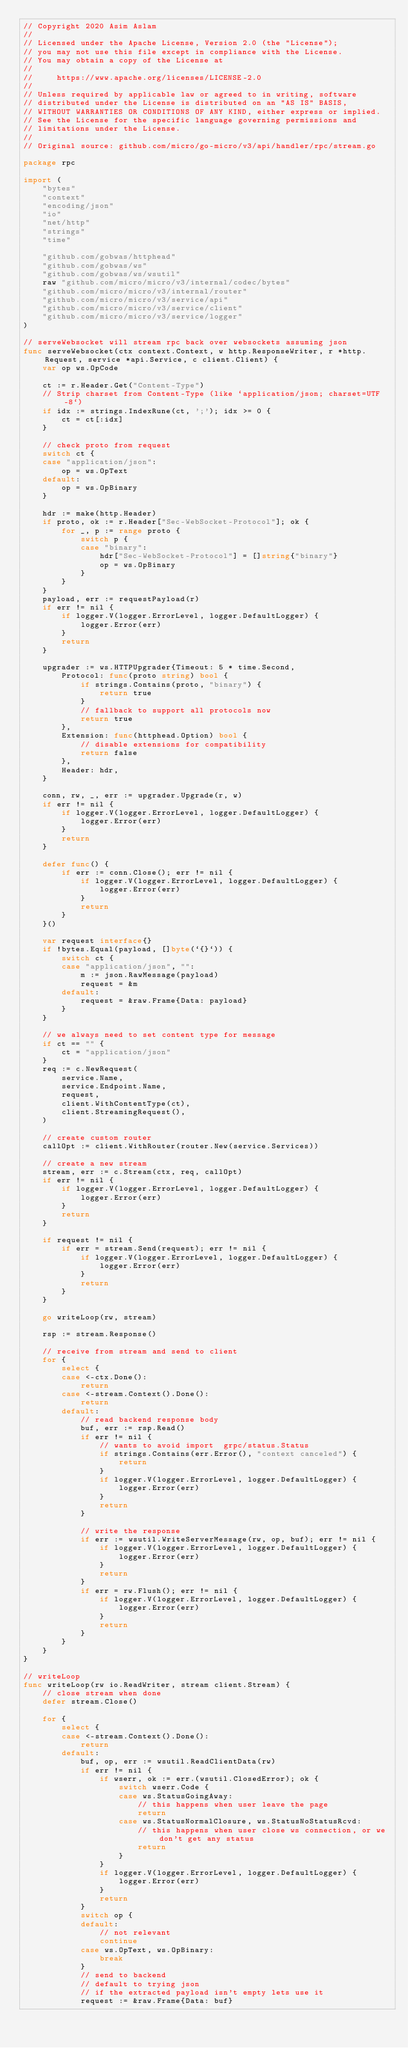<code> <loc_0><loc_0><loc_500><loc_500><_Go_>// Copyright 2020 Asim Aslam
//
// Licensed under the Apache License, Version 2.0 (the "License");
// you may not use this file except in compliance with the License.
// You may obtain a copy of the License at
//
//     https://www.apache.org/licenses/LICENSE-2.0
//
// Unless required by applicable law or agreed to in writing, software
// distributed under the License is distributed on an "AS IS" BASIS,
// WITHOUT WARRANTIES OR CONDITIONS OF ANY KIND, either express or implied.
// See the License for the specific language governing permissions and
// limitations under the License.
//
// Original source: github.com/micro/go-micro/v3/api/handler/rpc/stream.go

package rpc

import (
	"bytes"
	"context"
	"encoding/json"
	"io"
	"net/http"
	"strings"
	"time"

	"github.com/gobwas/httphead"
	"github.com/gobwas/ws"
	"github.com/gobwas/ws/wsutil"
	raw "github.com/micro/micro/v3/internal/codec/bytes"
	"github.com/micro/micro/v3/internal/router"
	"github.com/micro/micro/v3/service/api"
	"github.com/micro/micro/v3/service/client"
	"github.com/micro/micro/v3/service/logger"
)

// serveWebsocket will stream rpc back over websockets assuming json
func serveWebsocket(ctx context.Context, w http.ResponseWriter, r *http.Request, service *api.Service, c client.Client) {
	var op ws.OpCode

	ct := r.Header.Get("Content-Type")
	// Strip charset from Content-Type (like `application/json; charset=UTF-8`)
	if idx := strings.IndexRune(ct, ';'); idx >= 0 {
		ct = ct[:idx]
	}

	// check proto from request
	switch ct {
	case "application/json":
		op = ws.OpText
	default:
		op = ws.OpBinary
	}

	hdr := make(http.Header)
	if proto, ok := r.Header["Sec-WebSocket-Protocol"]; ok {
		for _, p := range proto {
			switch p {
			case "binary":
				hdr["Sec-WebSocket-Protocol"] = []string{"binary"}
				op = ws.OpBinary
			}
		}
	}
	payload, err := requestPayload(r)
	if err != nil {
		if logger.V(logger.ErrorLevel, logger.DefaultLogger) {
			logger.Error(err)
		}
		return
	}

	upgrader := ws.HTTPUpgrader{Timeout: 5 * time.Second,
		Protocol: func(proto string) bool {
			if strings.Contains(proto, "binary") {
				return true
			}
			// fallback to support all protocols now
			return true
		},
		Extension: func(httphead.Option) bool {
			// disable extensions for compatibility
			return false
		},
		Header: hdr,
	}

	conn, rw, _, err := upgrader.Upgrade(r, w)
	if err != nil {
		if logger.V(logger.ErrorLevel, logger.DefaultLogger) {
			logger.Error(err)
		}
		return
	}

	defer func() {
		if err := conn.Close(); err != nil {
			if logger.V(logger.ErrorLevel, logger.DefaultLogger) {
				logger.Error(err)
			}
			return
		}
	}()

	var request interface{}
	if !bytes.Equal(payload, []byte(`{}`)) {
		switch ct {
		case "application/json", "":
			m := json.RawMessage(payload)
			request = &m
		default:
			request = &raw.Frame{Data: payload}
		}
	}

	// we always need to set content type for message
	if ct == "" {
		ct = "application/json"
	}
	req := c.NewRequest(
		service.Name,
		service.Endpoint.Name,
		request,
		client.WithContentType(ct),
		client.StreamingRequest(),
	)

	// create custom router
	callOpt := client.WithRouter(router.New(service.Services))

	// create a new stream
	stream, err := c.Stream(ctx, req, callOpt)
	if err != nil {
		if logger.V(logger.ErrorLevel, logger.DefaultLogger) {
			logger.Error(err)
		}
		return
	}

	if request != nil {
		if err = stream.Send(request); err != nil {
			if logger.V(logger.ErrorLevel, logger.DefaultLogger) {
				logger.Error(err)
			}
			return
		}
	}

	go writeLoop(rw, stream)

	rsp := stream.Response()

	// receive from stream and send to client
	for {
		select {
		case <-ctx.Done():
			return
		case <-stream.Context().Done():
			return
		default:
			// read backend response body
			buf, err := rsp.Read()
			if err != nil {
				// wants to avoid import  grpc/status.Status
				if strings.Contains(err.Error(), "context canceled") {
					return
				}
				if logger.V(logger.ErrorLevel, logger.DefaultLogger) {
					logger.Error(err)
				}
				return
			}

			// write the response
			if err := wsutil.WriteServerMessage(rw, op, buf); err != nil {
				if logger.V(logger.ErrorLevel, logger.DefaultLogger) {
					logger.Error(err)
				}
				return
			}
			if err = rw.Flush(); err != nil {
				if logger.V(logger.ErrorLevel, logger.DefaultLogger) {
					logger.Error(err)
				}
				return
			}
		}
	}
}

// writeLoop
func writeLoop(rw io.ReadWriter, stream client.Stream) {
	// close stream when done
	defer stream.Close()

	for {
		select {
		case <-stream.Context().Done():
			return
		default:
			buf, op, err := wsutil.ReadClientData(rw)
			if err != nil {
				if wserr, ok := err.(wsutil.ClosedError); ok {
					switch wserr.Code {
					case ws.StatusGoingAway:
						// this happens when user leave the page
						return
					case ws.StatusNormalClosure, ws.StatusNoStatusRcvd:
						// this happens when user close ws connection, or we don't get any status
						return
					}
				}
				if logger.V(logger.ErrorLevel, logger.DefaultLogger) {
					logger.Error(err)
				}
				return
			}
			switch op {
			default:
				// not relevant
				continue
			case ws.OpText, ws.OpBinary:
				break
			}
			// send to backend
			// default to trying json
			// if the extracted payload isn't empty lets use it
			request := &raw.Frame{Data: buf}</code> 